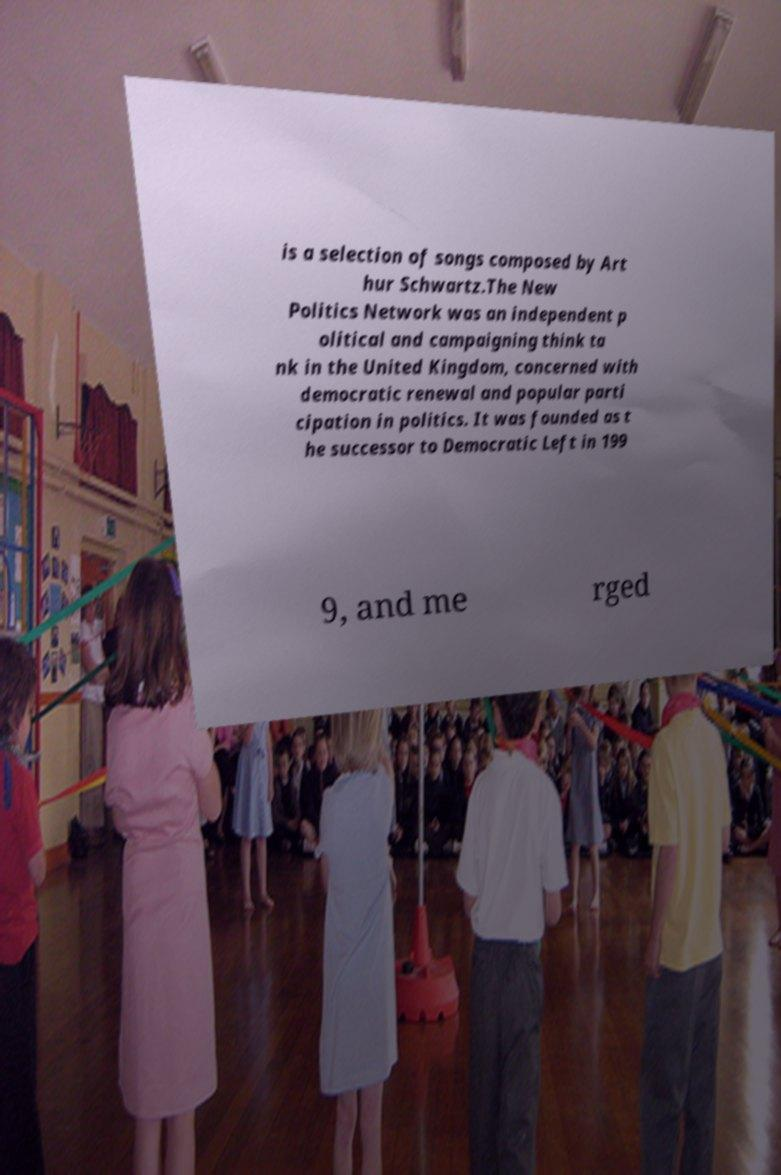What messages or text are displayed in this image? I need them in a readable, typed format. is a selection of songs composed by Art hur Schwartz.The New Politics Network was an independent p olitical and campaigning think ta nk in the United Kingdom, concerned with democratic renewal and popular parti cipation in politics. It was founded as t he successor to Democratic Left in 199 9, and me rged 